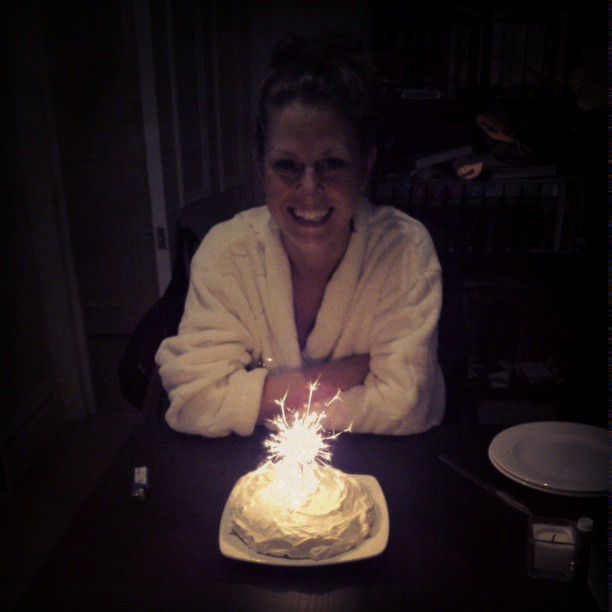What time of day does it appear to be at this birthday celebration? Considering the dark background and lighting in the room, it suggests the celebration is taking place in the evening or at night, creating a warm and inviting atmosphere. 